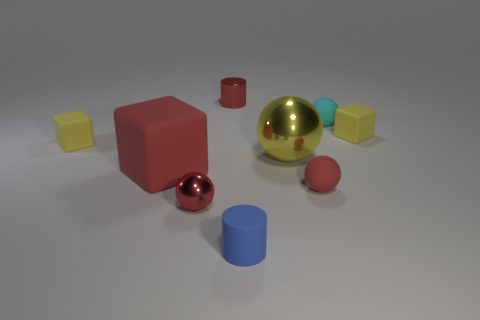What is the material of the blue thing that is the same size as the cyan thing?
Provide a succinct answer. Rubber. What number of other objects are the same size as the shiny cylinder?
Make the answer very short. 6. How many cylinders are either red matte objects or tiny cyan objects?
Offer a very short reply. 0. Are there any other things that are the same material as the red block?
Make the answer very short. Yes. What material is the big object on the right side of the small metal object that is behind the tiny yellow thing to the left of the tiny blue rubber thing?
Offer a terse response. Metal. There is a big cube that is the same color as the small shiny sphere; what is its material?
Provide a short and direct response. Rubber. What number of large spheres are the same material as the small cyan thing?
Give a very brief answer. 0. Do the cylinder in front of the cyan object and the large red thing have the same size?
Offer a very short reply. No. What is the color of the cylinder that is made of the same material as the cyan object?
Provide a short and direct response. Blue. Is there anything else that is the same size as the red metal cylinder?
Your answer should be very brief. Yes. 